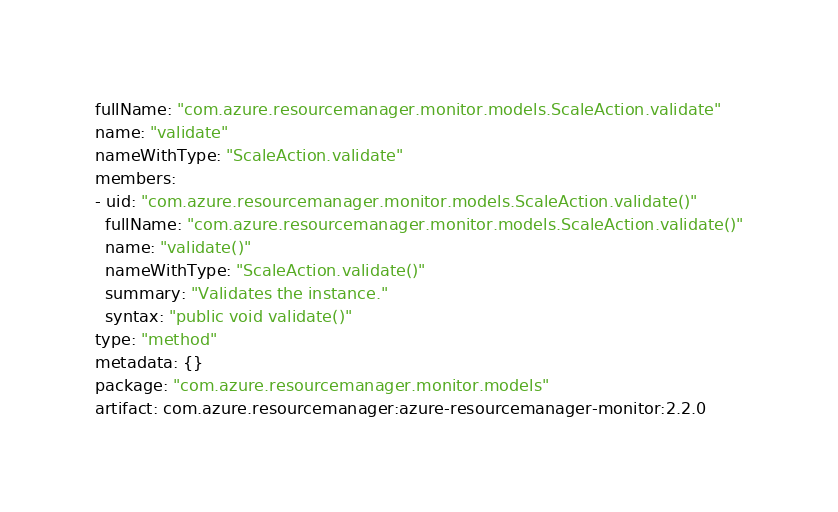Convert code to text. <code><loc_0><loc_0><loc_500><loc_500><_YAML_>fullName: "com.azure.resourcemanager.monitor.models.ScaleAction.validate"
name: "validate"
nameWithType: "ScaleAction.validate"
members:
- uid: "com.azure.resourcemanager.monitor.models.ScaleAction.validate()"
  fullName: "com.azure.resourcemanager.monitor.models.ScaleAction.validate()"
  name: "validate()"
  nameWithType: "ScaleAction.validate()"
  summary: "Validates the instance."
  syntax: "public void validate()"
type: "method"
metadata: {}
package: "com.azure.resourcemanager.monitor.models"
artifact: com.azure.resourcemanager:azure-resourcemanager-monitor:2.2.0
</code> 